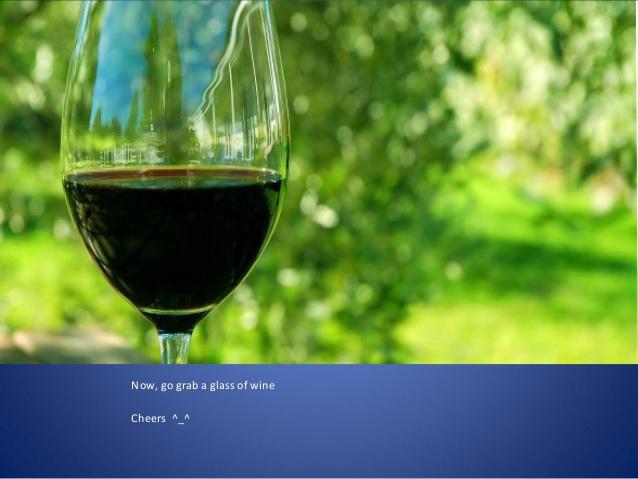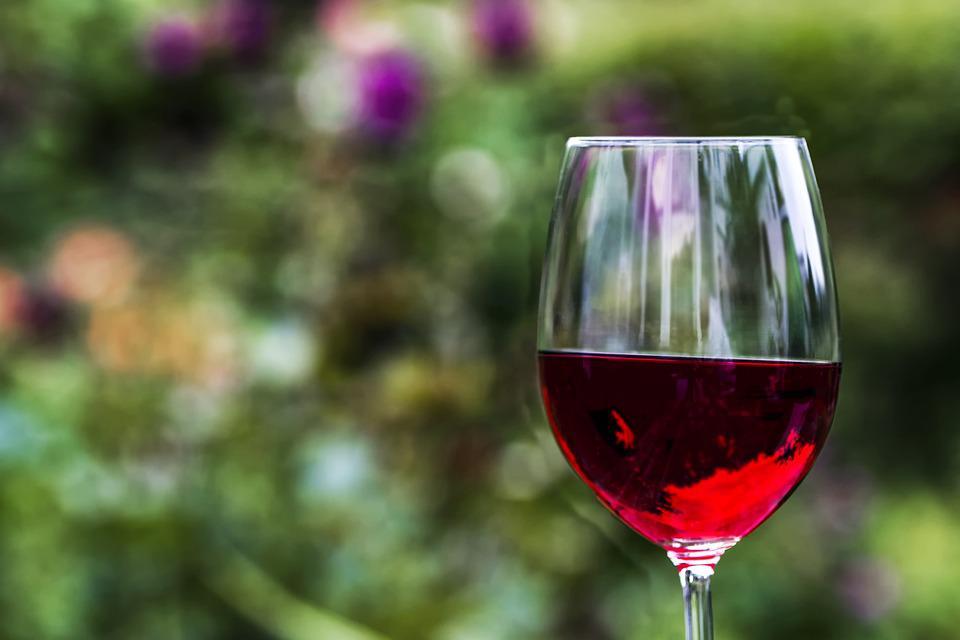The first image is the image on the left, the second image is the image on the right. Evaluate the accuracy of this statement regarding the images: "Wine is being poured in at least one image.". Is it true? Answer yes or no. No. The first image is the image on the left, the second image is the image on the right. For the images shown, is this caption "There is a wine bottle in the iamge on the left" true? Answer yes or no. No. 